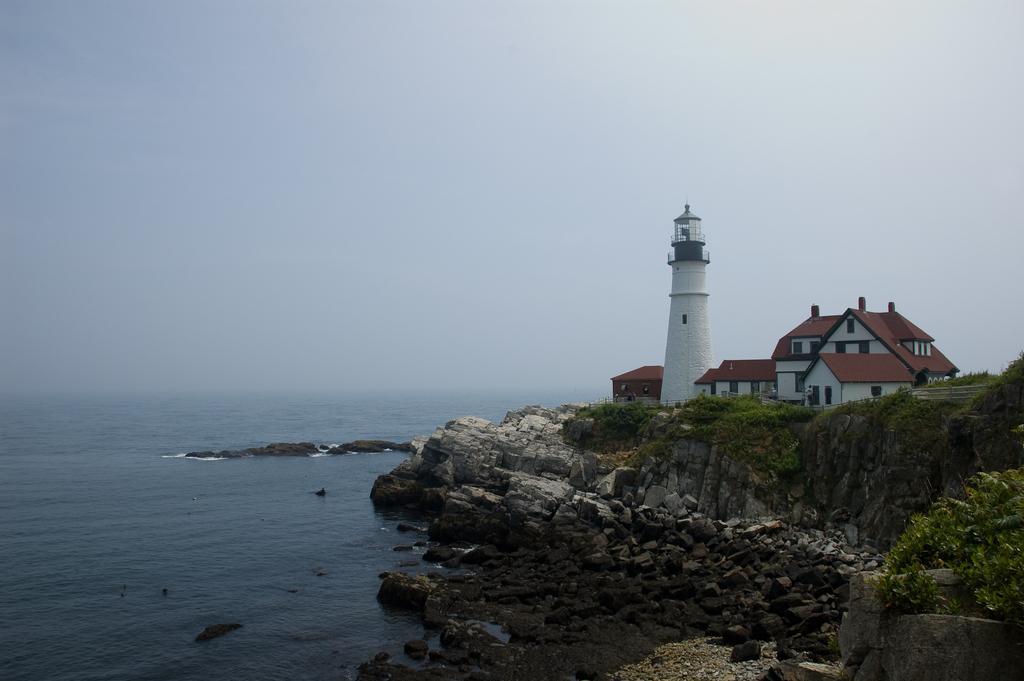Could you give a brief overview of what you see in this image? In the picture I can see houses, a tower, rocks, plants, rocks and the water. In the background I can see the sky. 